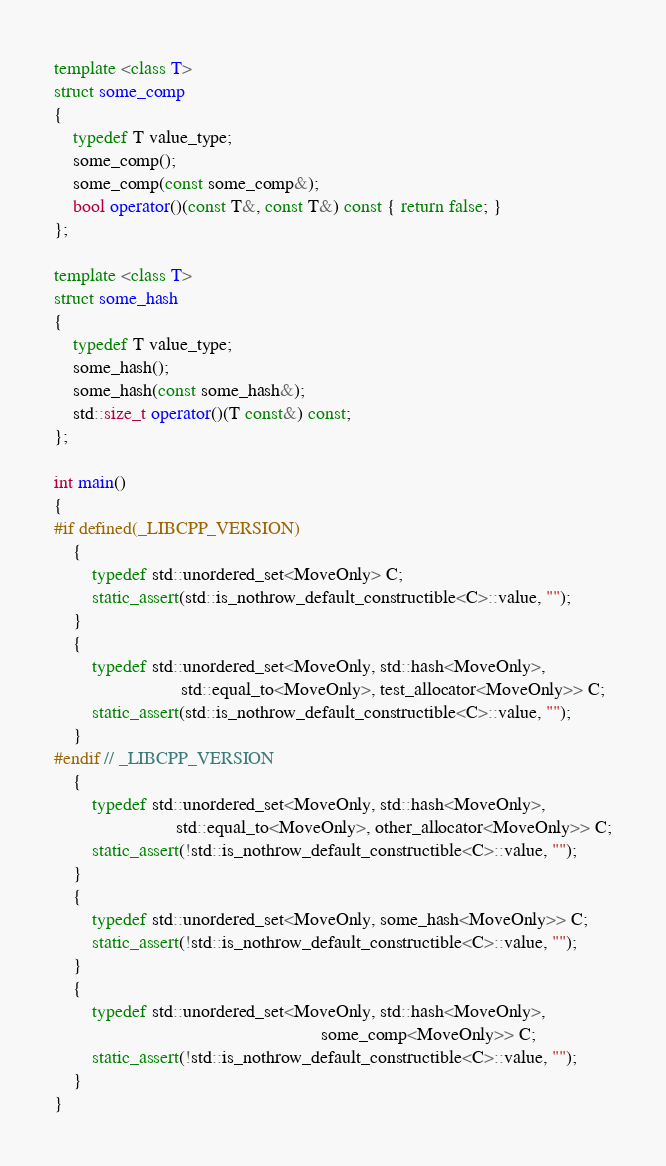<code> <loc_0><loc_0><loc_500><loc_500><_C++_>
template <class T>
struct some_comp
{
    typedef T value_type;
    some_comp();
    some_comp(const some_comp&);
    bool operator()(const T&, const T&) const { return false; }
};

template <class T>
struct some_hash
{
    typedef T value_type;
    some_hash();
    some_hash(const some_hash&);
    std::size_t operator()(T const&) const;
};

int main()
{
#if defined(_LIBCPP_VERSION)
    {
        typedef std::unordered_set<MoveOnly> C;
        static_assert(std::is_nothrow_default_constructible<C>::value, "");
    }
    {
        typedef std::unordered_set<MoveOnly, std::hash<MoveOnly>,
                           std::equal_to<MoveOnly>, test_allocator<MoveOnly>> C;
        static_assert(std::is_nothrow_default_constructible<C>::value, "");
    }
#endif // _LIBCPP_VERSION
    {
        typedef std::unordered_set<MoveOnly, std::hash<MoveOnly>,
                          std::equal_to<MoveOnly>, other_allocator<MoveOnly>> C;
        static_assert(!std::is_nothrow_default_constructible<C>::value, "");
    }
    {
        typedef std::unordered_set<MoveOnly, some_hash<MoveOnly>> C;
        static_assert(!std::is_nothrow_default_constructible<C>::value, "");
    }
    {
        typedef std::unordered_set<MoveOnly, std::hash<MoveOnly>,
                                                         some_comp<MoveOnly>> C;
        static_assert(!std::is_nothrow_default_constructible<C>::value, "");
    }
}
</code> 